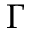Convert formula to latex. <formula><loc_0><loc_0><loc_500><loc_500>\Gamma</formula> 